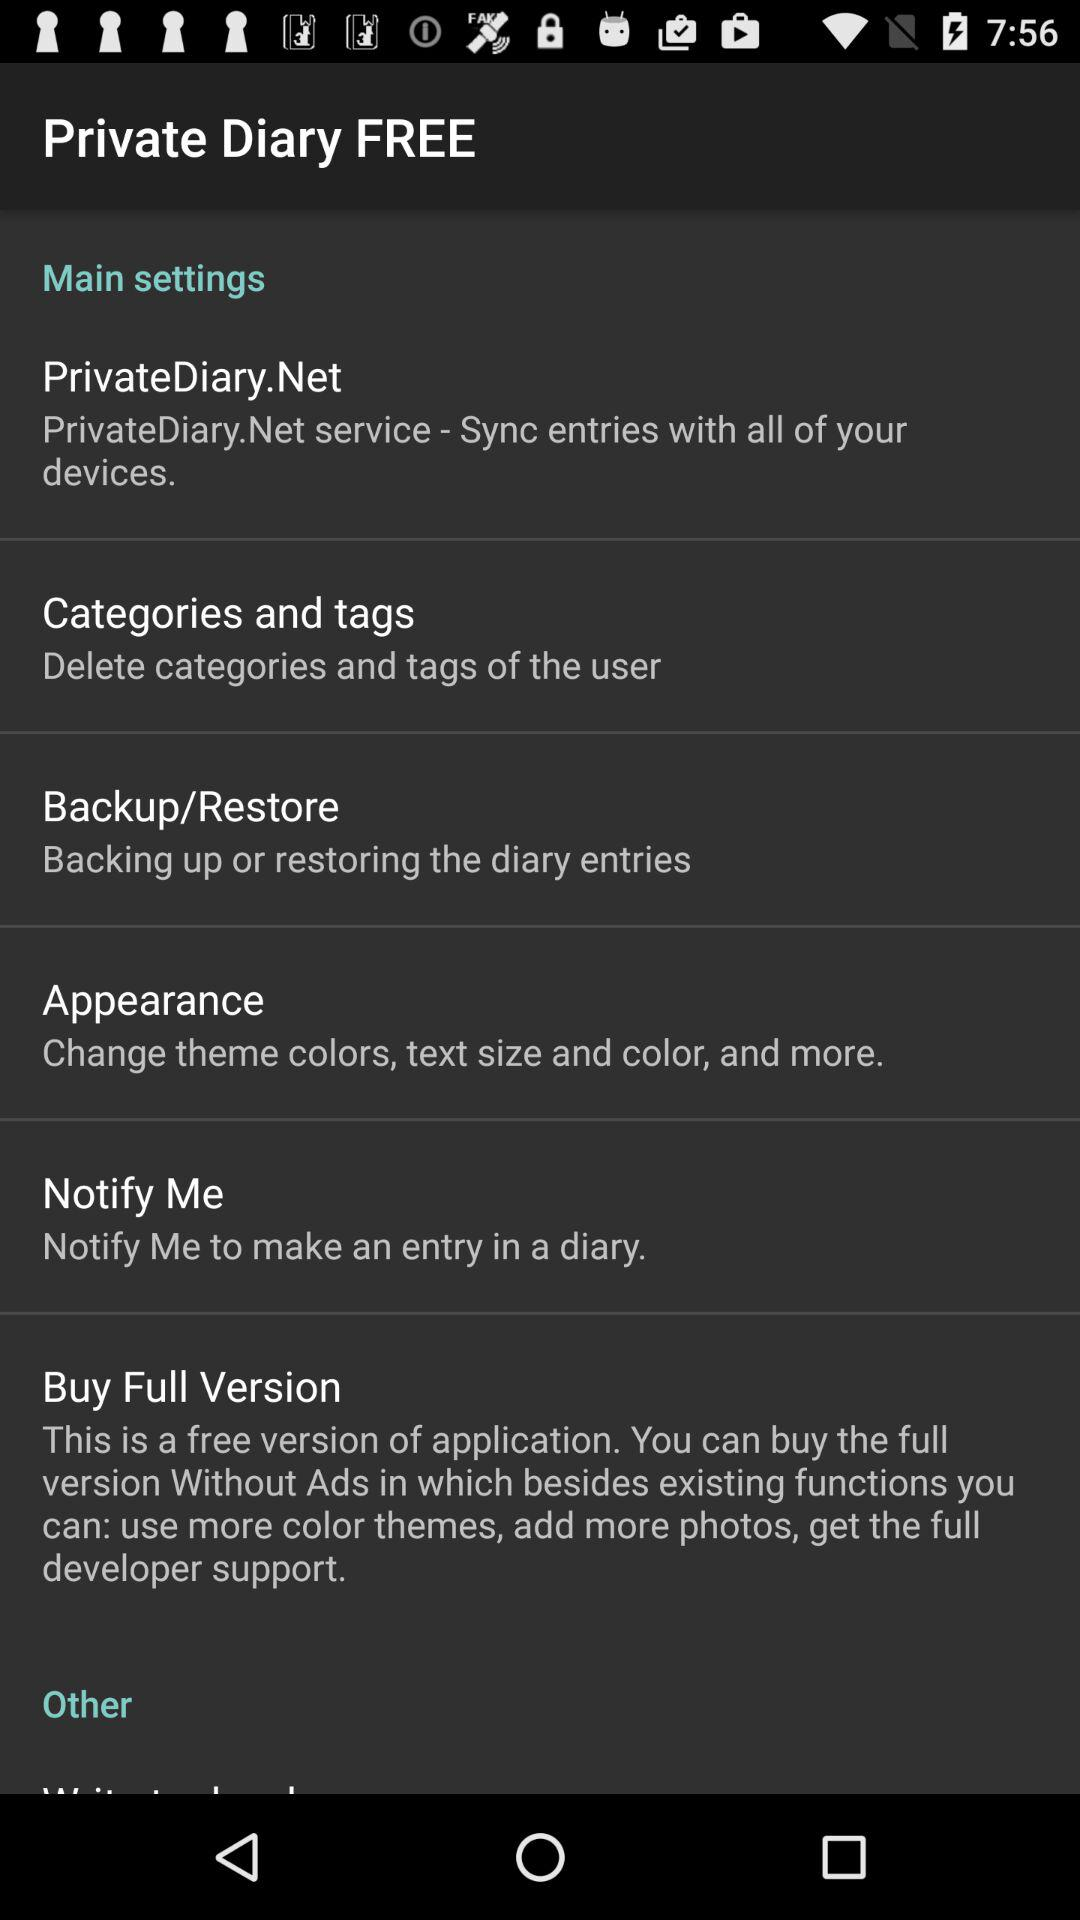What is the description of "Categories and tags"? The description of "Categories and tags" is "Delete categories and tags of the user". 